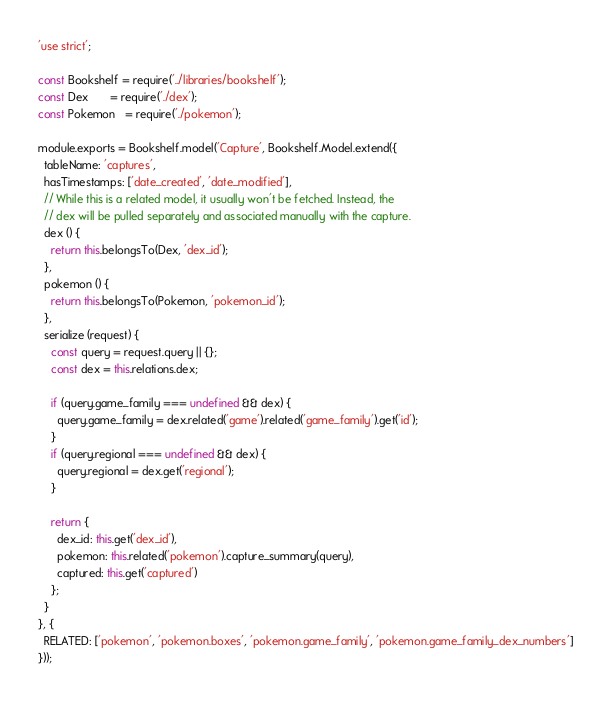<code> <loc_0><loc_0><loc_500><loc_500><_JavaScript_>'use strict';

const Bookshelf = require('../libraries/bookshelf');
const Dex       = require('./dex');
const Pokemon   = require('./pokemon');

module.exports = Bookshelf.model('Capture', Bookshelf.Model.extend({
  tableName: 'captures',
  hasTimestamps: ['date_created', 'date_modified'],
  // While this is a related model, it usually won't be fetched. Instead, the
  // dex will be pulled separately and associated manually with the capture.
  dex () {
    return this.belongsTo(Dex, 'dex_id');
  },
  pokemon () {
    return this.belongsTo(Pokemon, 'pokemon_id');
  },
  serialize (request) {
    const query = request.query || {};
    const dex = this.relations.dex;

    if (query.game_family === undefined && dex) {
      query.game_family = dex.related('game').related('game_family').get('id');
    }
    if (query.regional === undefined && dex) {
      query.regional = dex.get('regional');
    }

    return {
      dex_id: this.get('dex_id'),
      pokemon: this.related('pokemon').capture_summary(query),
      captured: this.get('captured')
    };
  }
}, {
  RELATED: ['pokemon', 'pokemon.boxes', 'pokemon.game_family', 'pokemon.game_family_dex_numbers']
}));
</code> 